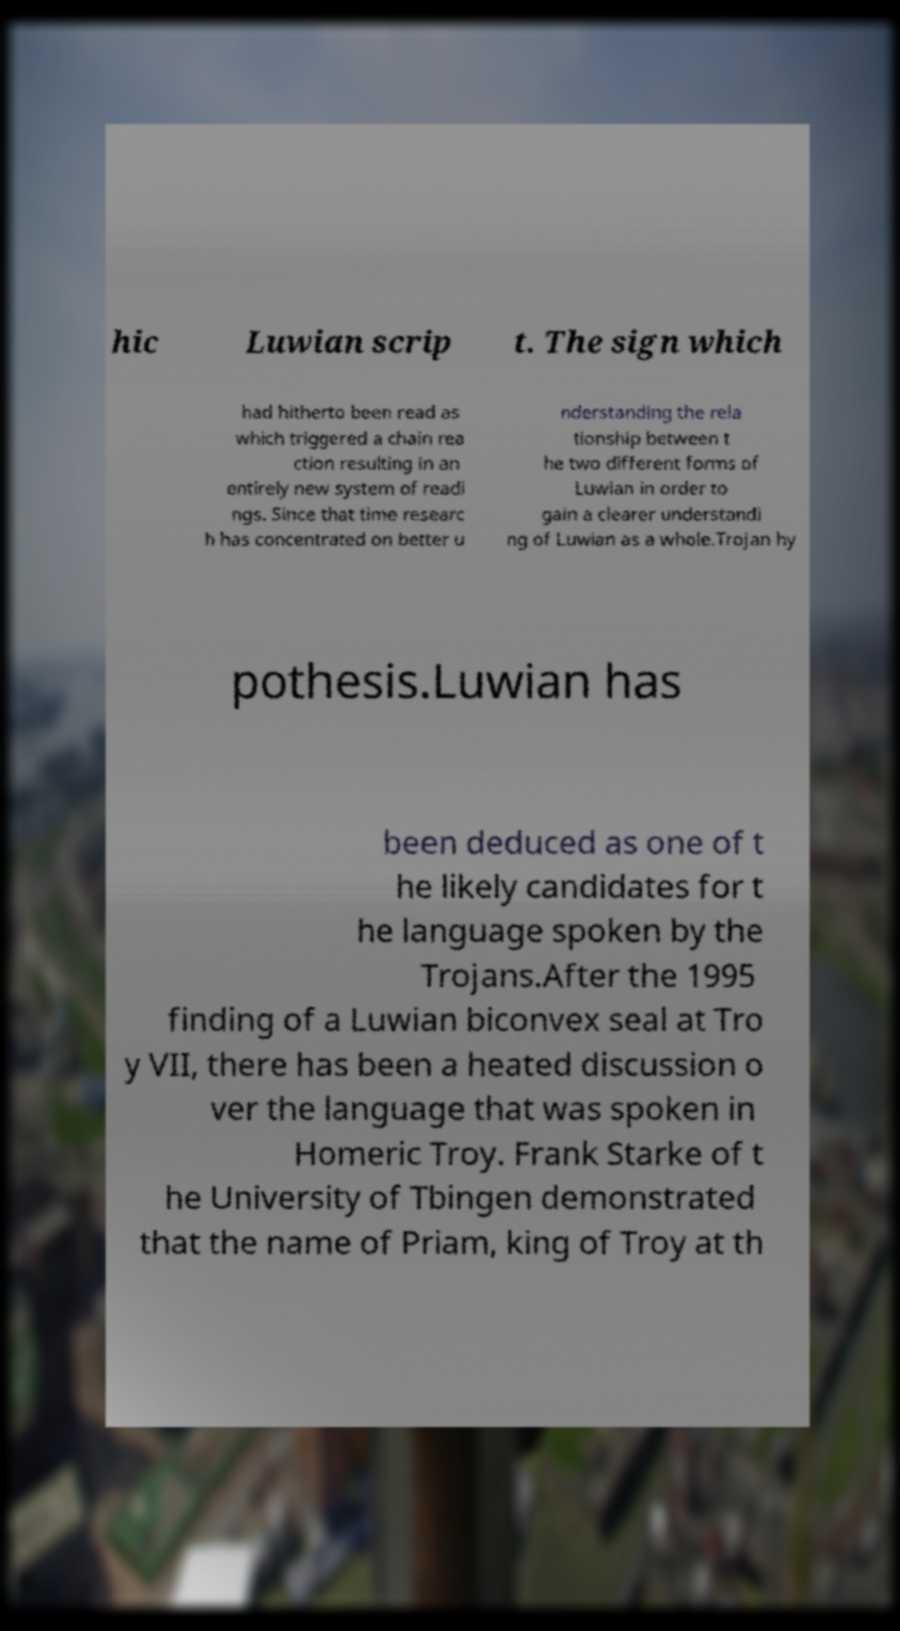Could you extract and type out the text from this image? hic Luwian scrip t. The sign which had hitherto been read as which triggered a chain rea ction resulting in an entirely new system of readi ngs. Since that time researc h has concentrated on better u nderstanding the rela tionship between t he two different forms of Luwian in order to gain a clearer understandi ng of Luwian as a whole.Trojan hy pothesis.Luwian has been deduced as one of t he likely candidates for t he language spoken by the Trojans.After the 1995 finding of a Luwian biconvex seal at Tro y VII, there has been a heated discussion o ver the language that was spoken in Homeric Troy. Frank Starke of t he University of Tbingen demonstrated that the name of Priam, king of Troy at th 